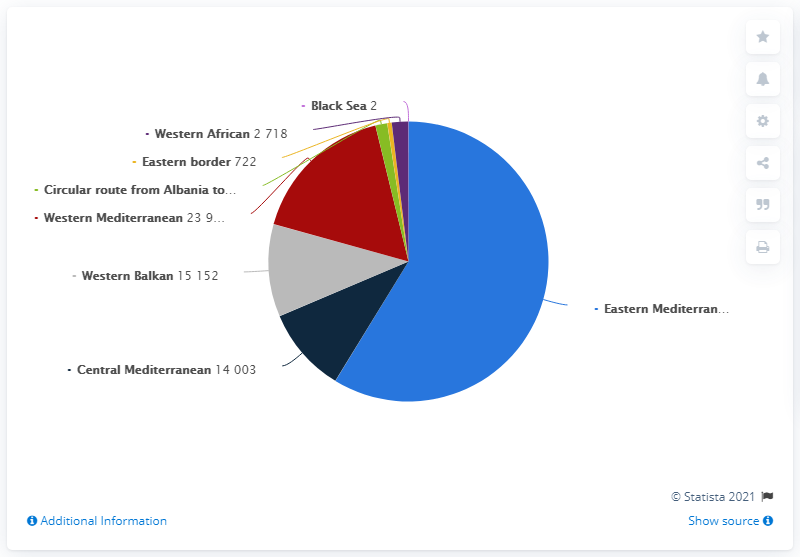Highlight a few significant elements in this photo. The difference between Black Sea and Western African is 0.718... In 2019, the highest number of illegal border crossings was detected, which was 83,333. The number of illegal border crossings between border crossing points to the European Union (EU) in 2019 was the lowest on the Black Sea route, with only 2 reported instances. 